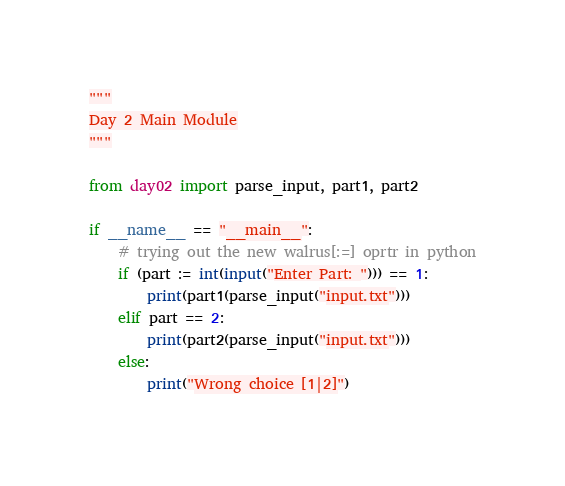Convert code to text. <code><loc_0><loc_0><loc_500><loc_500><_Python_>"""
Day 2 Main Module
"""

from day02 import parse_input, part1, part2

if __name__ == "__main__":
    # trying out the new walrus[:=] oprtr in python
    if (part := int(input("Enter Part: "))) == 1:
        print(part1(parse_input("input.txt")))
    elif part == 2:
        print(part2(parse_input("input.txt")))
    else:
        print("Wrong choice [1|2]")
</code> 